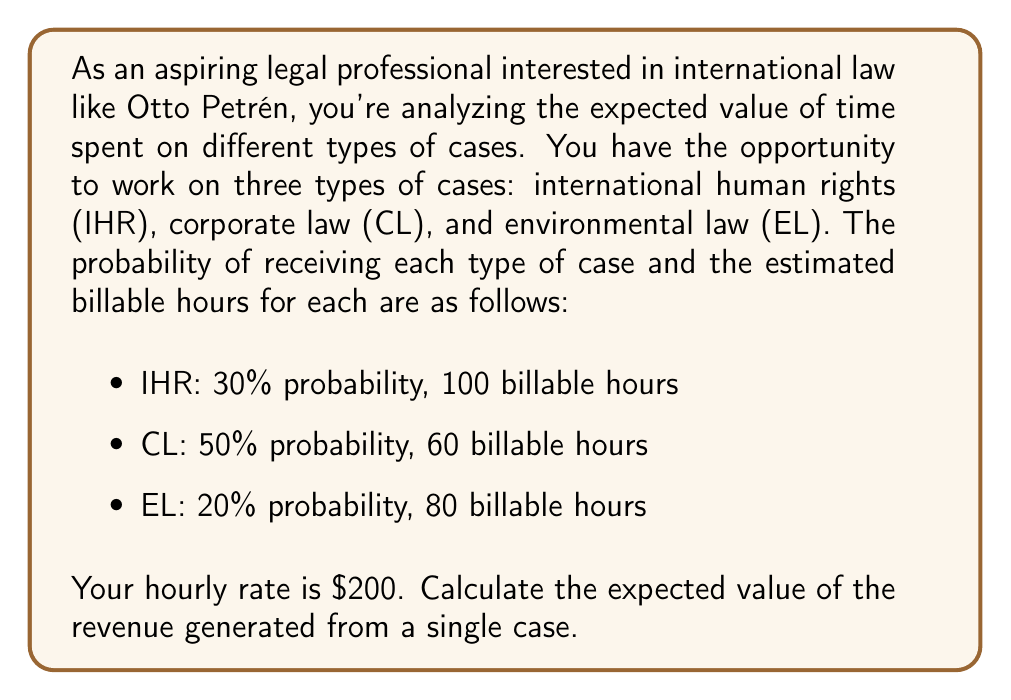Give your solution to this math problem. To solve this problem, we need to follow these steps:

1) First, let's recall the formula for expected value:
   $$ E(X) = \sum_{i=1}^{n} p_i \cdot x_i $$
   where $p_i$ is the probability of each outcome and $x_i$ is the value of each outcome.

2) In this case, the value of each outcome is the product of billable hours and the hourly rate. Let's calculate this for each case type:

   - IHR: 100 hours × $200/hour = $20,000
   - CL: 60 hours × $200/hour = $12,000
   - EL: 80 hours × $200/hour = $16,000

3) Now, let's apply the expected value formula:

   $$ E(X) = (0.30 \cdot 20000) + (0.50 \cdot 12000) + (0.20 \cdot 16000) $$

4) Let's calculate each term:
   
   $$ E(X) = 6000 + 6000 + 3200 $$

5) Sum up the terms:

   $$ E(X) = 15200 $$

Therefore, the expected value of the revenue generated from a single case is $15,200.
Answer: $15,200 